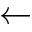Convert formula to latex. <formula><loc_0><loc_0><loc_500><loc_500>\gets</formula> 